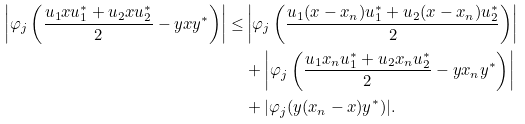Convert formula to latex. <formula><loc_0><loc_0><loc_500><loc_500>\left | \varphi _ { j } \left ( \frac { u _ { 1 } x u _ { 1 } ^ { * } + u _ { 2 } x u _ { 2 } ^ { * } } { 2 } - y x y ^ { * } \right ) \right | \leq & \left | \varphi _ { j } \left ( \frac { u _ { 1 } ( x - x _ { n } ) u _ { 1 } ^ { * } + u _ { 2 } ( x - x _ { n } ) u _ { 2 } ^ { * } } { 2 } \right ) \right | \\ & + \left | \varphi _ { j } \left ( \frac { u _ { 1 } x _ { n } u _ { 1 } ^ { * } + u _ { 2 } x _ { n } u _ { 2 } ^ { * } } { 2 } - y x _ { n } y ^ { * } \right ) \right | \\ & + | \varphi _ { j } ( y ( x _ { n } - x ) y ^ { * } ) | .</formula> 